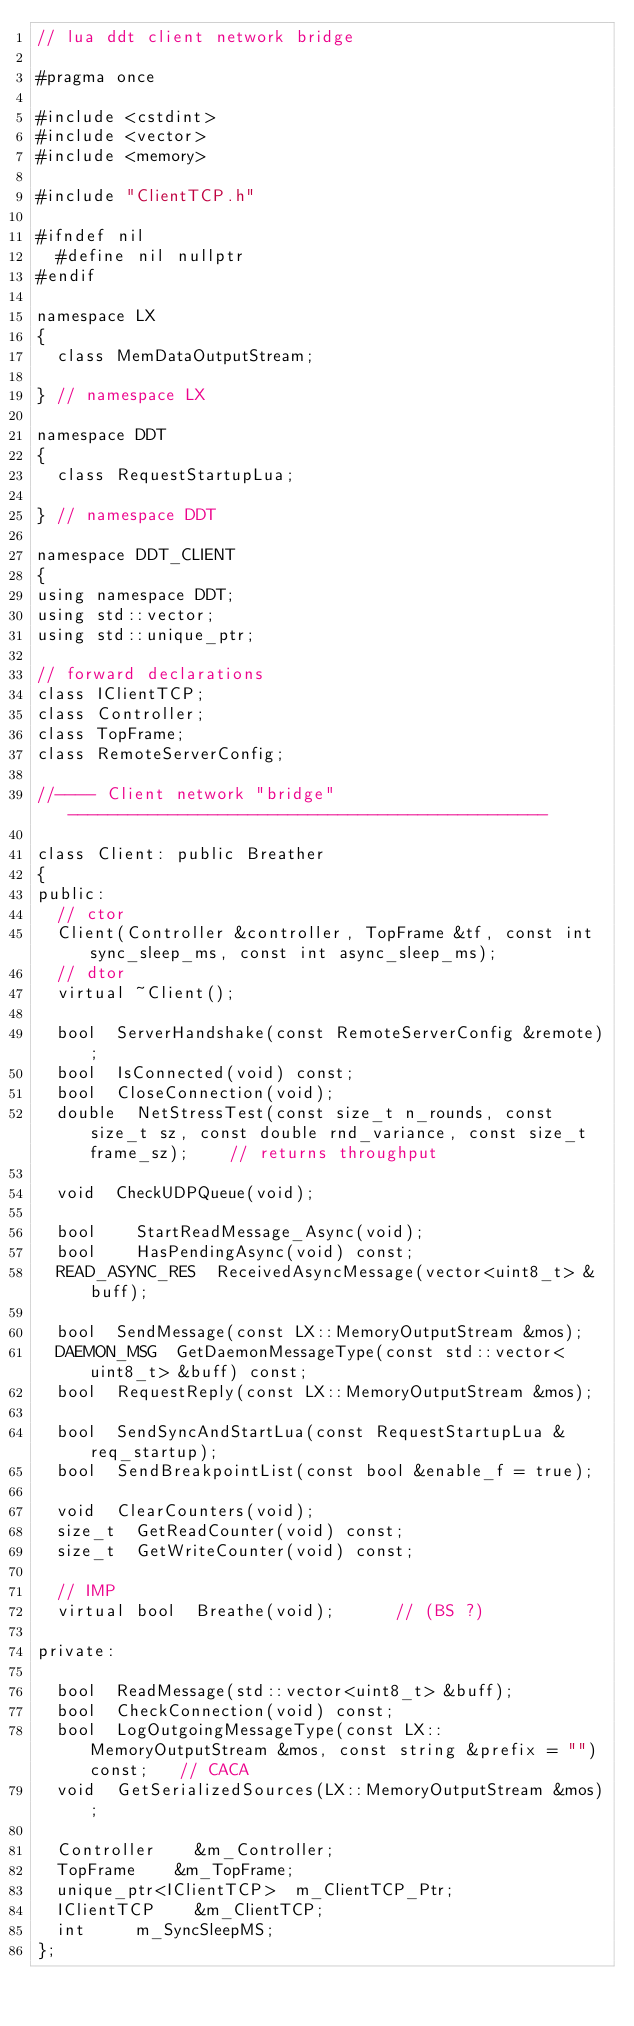Convert code to text. <code><loc_0><loc_0><loc_500><loc_500><_C_>// lua ddt client network bridge

#pragma once

#include <cstdint>
#include <vector>
#include <memory>

#include "ClientTCP.h"

#ifndef nil
	#define nil	nullptr
#endif

namespace LX
{
	class MemDataOutputStream;
	
} // namespace LX

namespace DDT
{
	class RequestStartupLua;
	
} // namespace DDT

namespace DDT_CLIENT
{
using namespace DDT;
using std::vector;
using std::unique_ptr;

// forward declarations
class IClientTCP;
class Controller;
class TopFrame;
class RemoteServerConfig;

//---- Client network "bridge" ------------------------------------------------

class Client: public Breather
{
public:
	// ctor
	Client(Controller &controller, TopFrame &tf, const int sync_sleep_ms, const int async_sleep_ms);
	// dtor
	virtual ~Client();
	
	bool	ServerHandshake(const RemoteServerConfig &remote);
	bool	IsConnected(void) const;
	bool	CloseConnection(void);
	double	NetStressTest(const size_t n_rounds, const size_t sz, const double rnd_variance, const size_t frame_sz);		// returns throughput
	
	void	CheckUDPQueue(void);

	bool		StartReadMessage_Async(void);
	bool		HasPendingAsync(void) const;
	READ_ASYNC_RES	ReceivedAsyncMessage(vector<uint8_t> &buff);
	
	bool	SendMessage(const LX::MemoryOutputStream &mos);
	DAEMON_MSG	GetDaemonMessageType(const std::vector<uint8_t> &buff) const;
	bool	RequestReply(const LX::MemoryOutputStream &mos);
	
	bool	SendSyncAndStartLua(const RequestStartupLua &req_startup);
	bool	SendBreakpointList(const bool &enable_f = true);
	
	void	ClearCounters(void);
	size_t	GetReadCounter(void) const;
	size_t	GetWriteCounter(void) const;
	
	// IMP
	virtual bool	Breathe(void);			// (BS ?)
	
private:

	bool	ReadMessage(std::vector<uint8_t> &buff);
	bool	CheckConnection(void) const;
	bool	LogOutgoingMessageType(const LX::MemoryOutputStream &mos, const string &prefix = "") const;		// CACA
	void	GetSerializedSources(LX::MemoryOutputStream &mos);
	
	Controller		&m_Controller;
	TopFrame		&m_TopFrame;
	unique_ptr<IClientTCP>	m_ClientTCP_Ptr;
	IClientTCP		&m_ClientTCP;
	int			m_SyncSleepMS;
};
</code> 